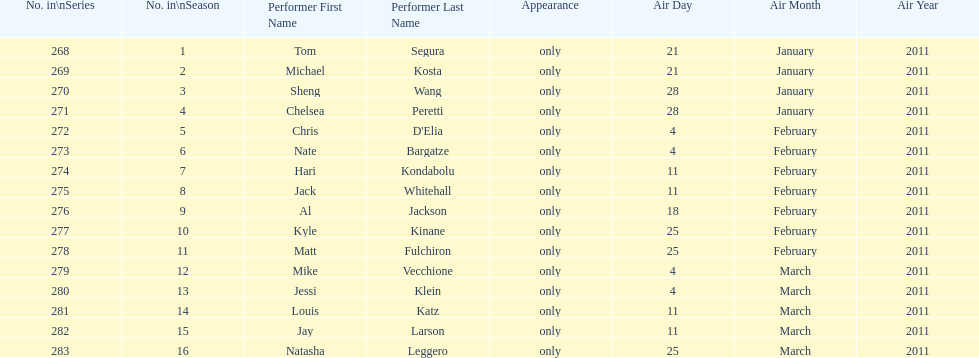How many different performers appeared during this season? 16. 